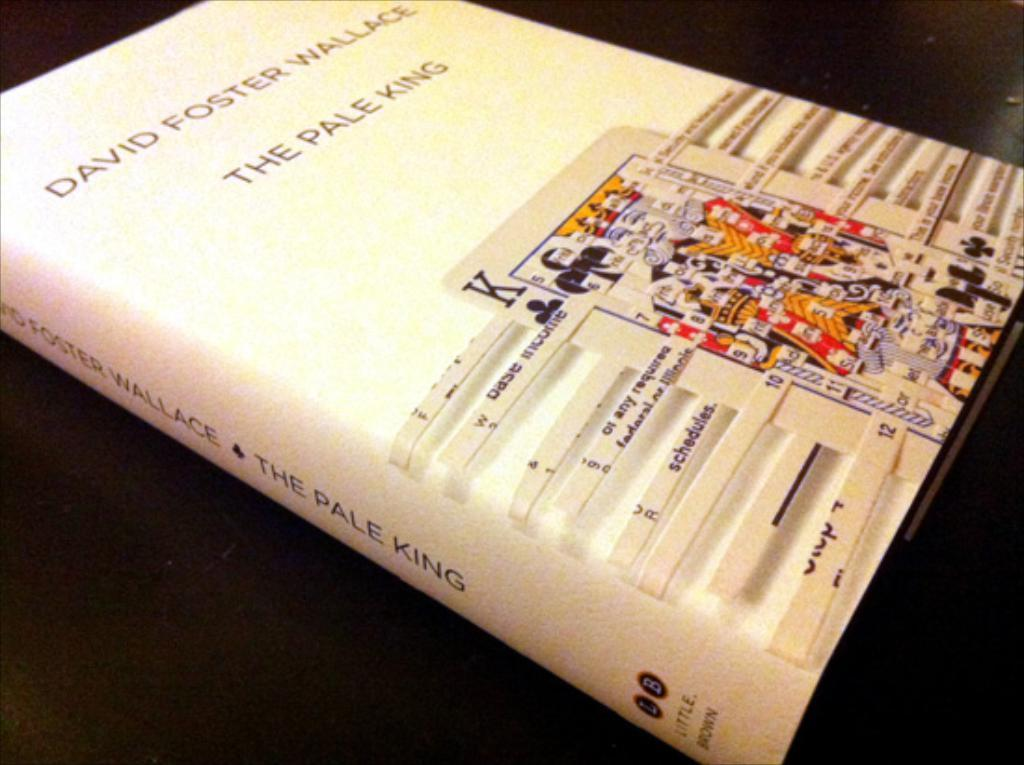<image>
Offer a succinct explanation of the picture presented. A David Foster Wallace novel that has a picture of a playing card on the front. 